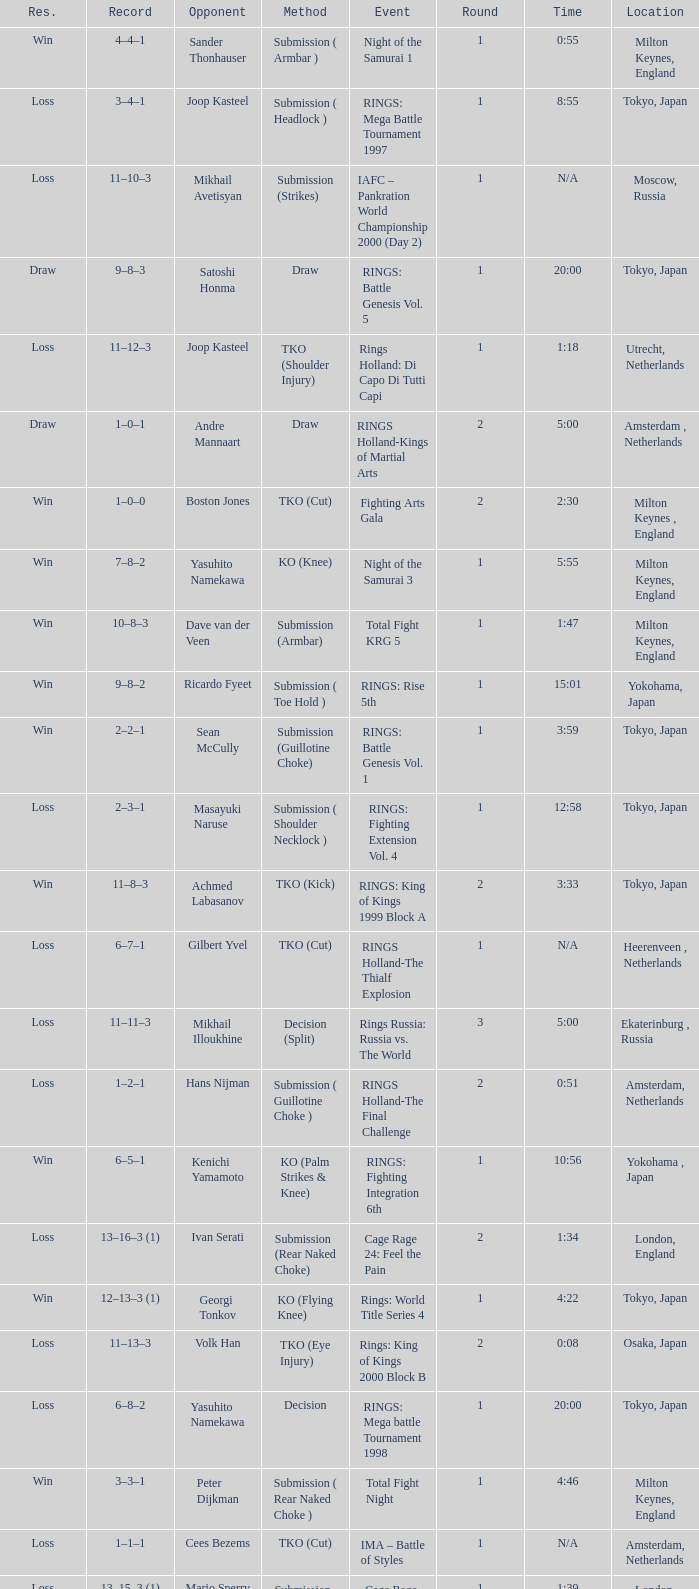Which event had an opponent of Yasuhito Namekawa with a decision method? RINGS: Mega battle Tournament 1998. 